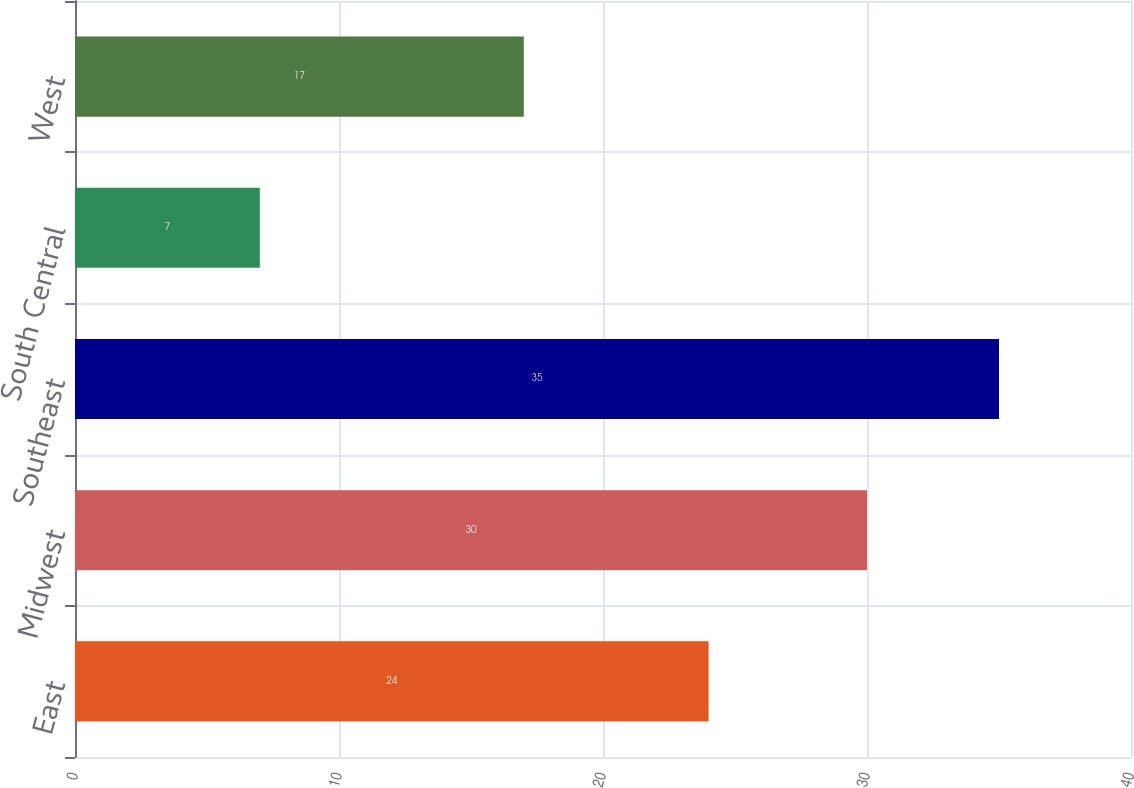Convert chart. <chart><loc_0><loc_0><loc_500><loc_500><bar_chart><fcel>East<fcel>Midwest<fcel>Southeast<fcel>South Central<fcel>West<nl><fcel>24<fcel>30<fcel>35<fcel>7<fcel>17<nl></chart> 